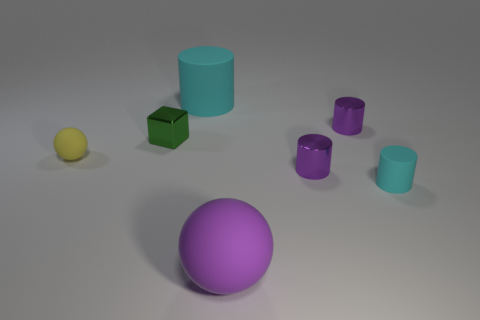Subtract all tiny cyan cylinders. How many cylinders are left? 3 Subtract 2 cylinders. How many cylinders are left? 2 Add 2 tiny purple metal objects. How many objects exist? 9 Subtract all brown cylinders. Subtract all brown spheres. How many cylinders are left? 4 Subtract all cylinders. How many objects are left? 3 Subtract all purple matte spheres. Subtract all big cyan objects. How many objects are left? 5 Add 4 purple things. How many purple things are left? 7 Add 6 small yellow metallic cubes. How many small yellow metallic cubes exist? 6 Subtract 0 gray cylinders. How many objects are left? 7 